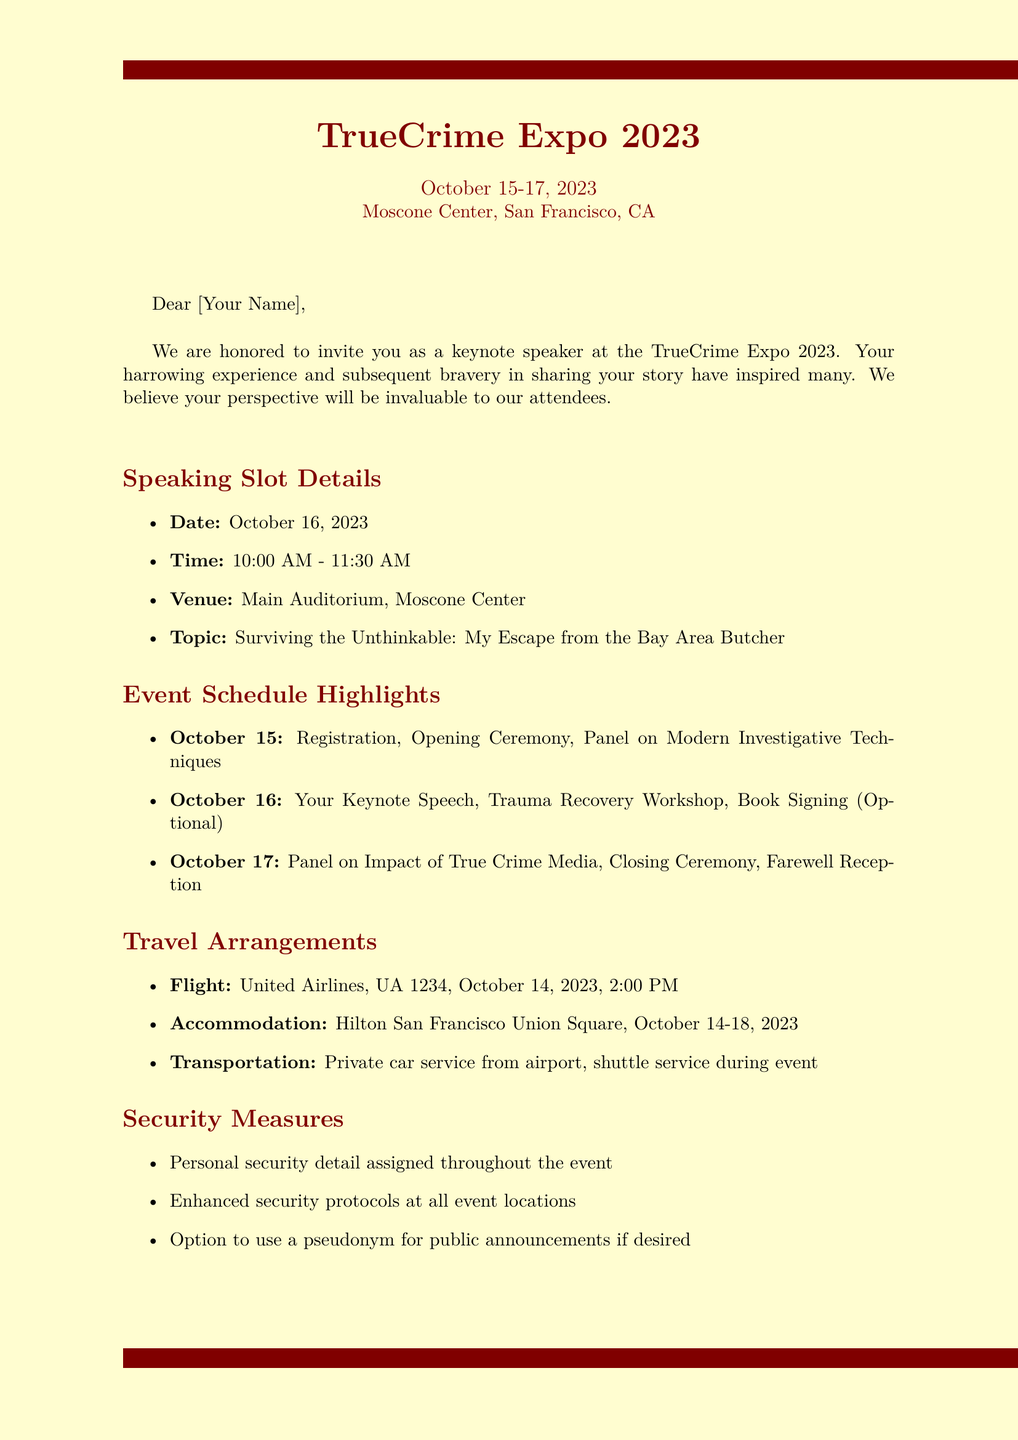What are the dates of the convention? The dates of the convention are mentioned in the document as October 15-17, 2023.
Answer: October 15-17, 2023 What is the venue for the keynote speech? The venue for the keynote speech is specified in the document under speaking slot details.
Answer: Main Auditorium, Moscone Center What is the honorarium for the speaking engagement? The honorarium is detailed in the additional information section of the document.
Answer: $5,000 What topic will be covered in the keynote speech? The topic of the speech is included in the speaking slot details section of the document.
Answer: Surviving the Unthinkable: My Escape from the Bay Area Butcher Which airline is providing the flight? The airline is noted under travel arrangements in the document.
Answer: United Airlines What time is the opening ceremony on October 15? The time for the opening ceremony is listed in the event schedule highlights for that date.
Answer: 11:00 AM What security measure is provided for the speaker during the event? Security measures are outlined in the document, specifying a personal security detail.
Answer: A personal security detail What is the check-out date from the hotel? The check-out date is provided under the accommodation section of the travel arrangements.
Answer: October 18, 2023 What optional event is mentioned for October 16? An optional event on October 16 is discussed in the event schedule highlights.
Answer: Book Signing Session 